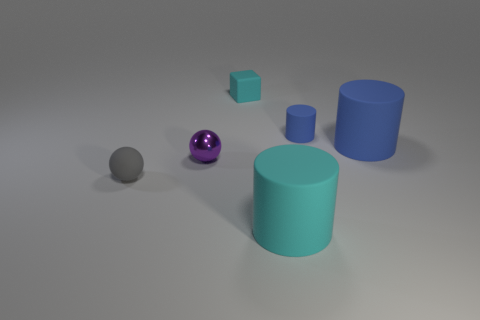Subtract all cyan rubber cylinders. How many cylinders are left? 2 Subtract all green blocks. How many blue cylinders are left? 2 Subtract 1 cylinders. How many cylinders are left? 2 Add 2 large blue cylinders. How many objects exist? 8 Subtract all green cylinders. Subtract all brown spheres. How many cylinders are left? 3 Subtract all brown objects. Subtract all gray balls. How many objects are left? 5 Add 4 cylinders. How many cylinders are left? 7 Add 4 cyan rubber cubes. How many cyan rubber cubes exist? 5 Subtract 0 green blocks. How many objects are left? 6 Subtract all spheres. How many objects are left? 4 